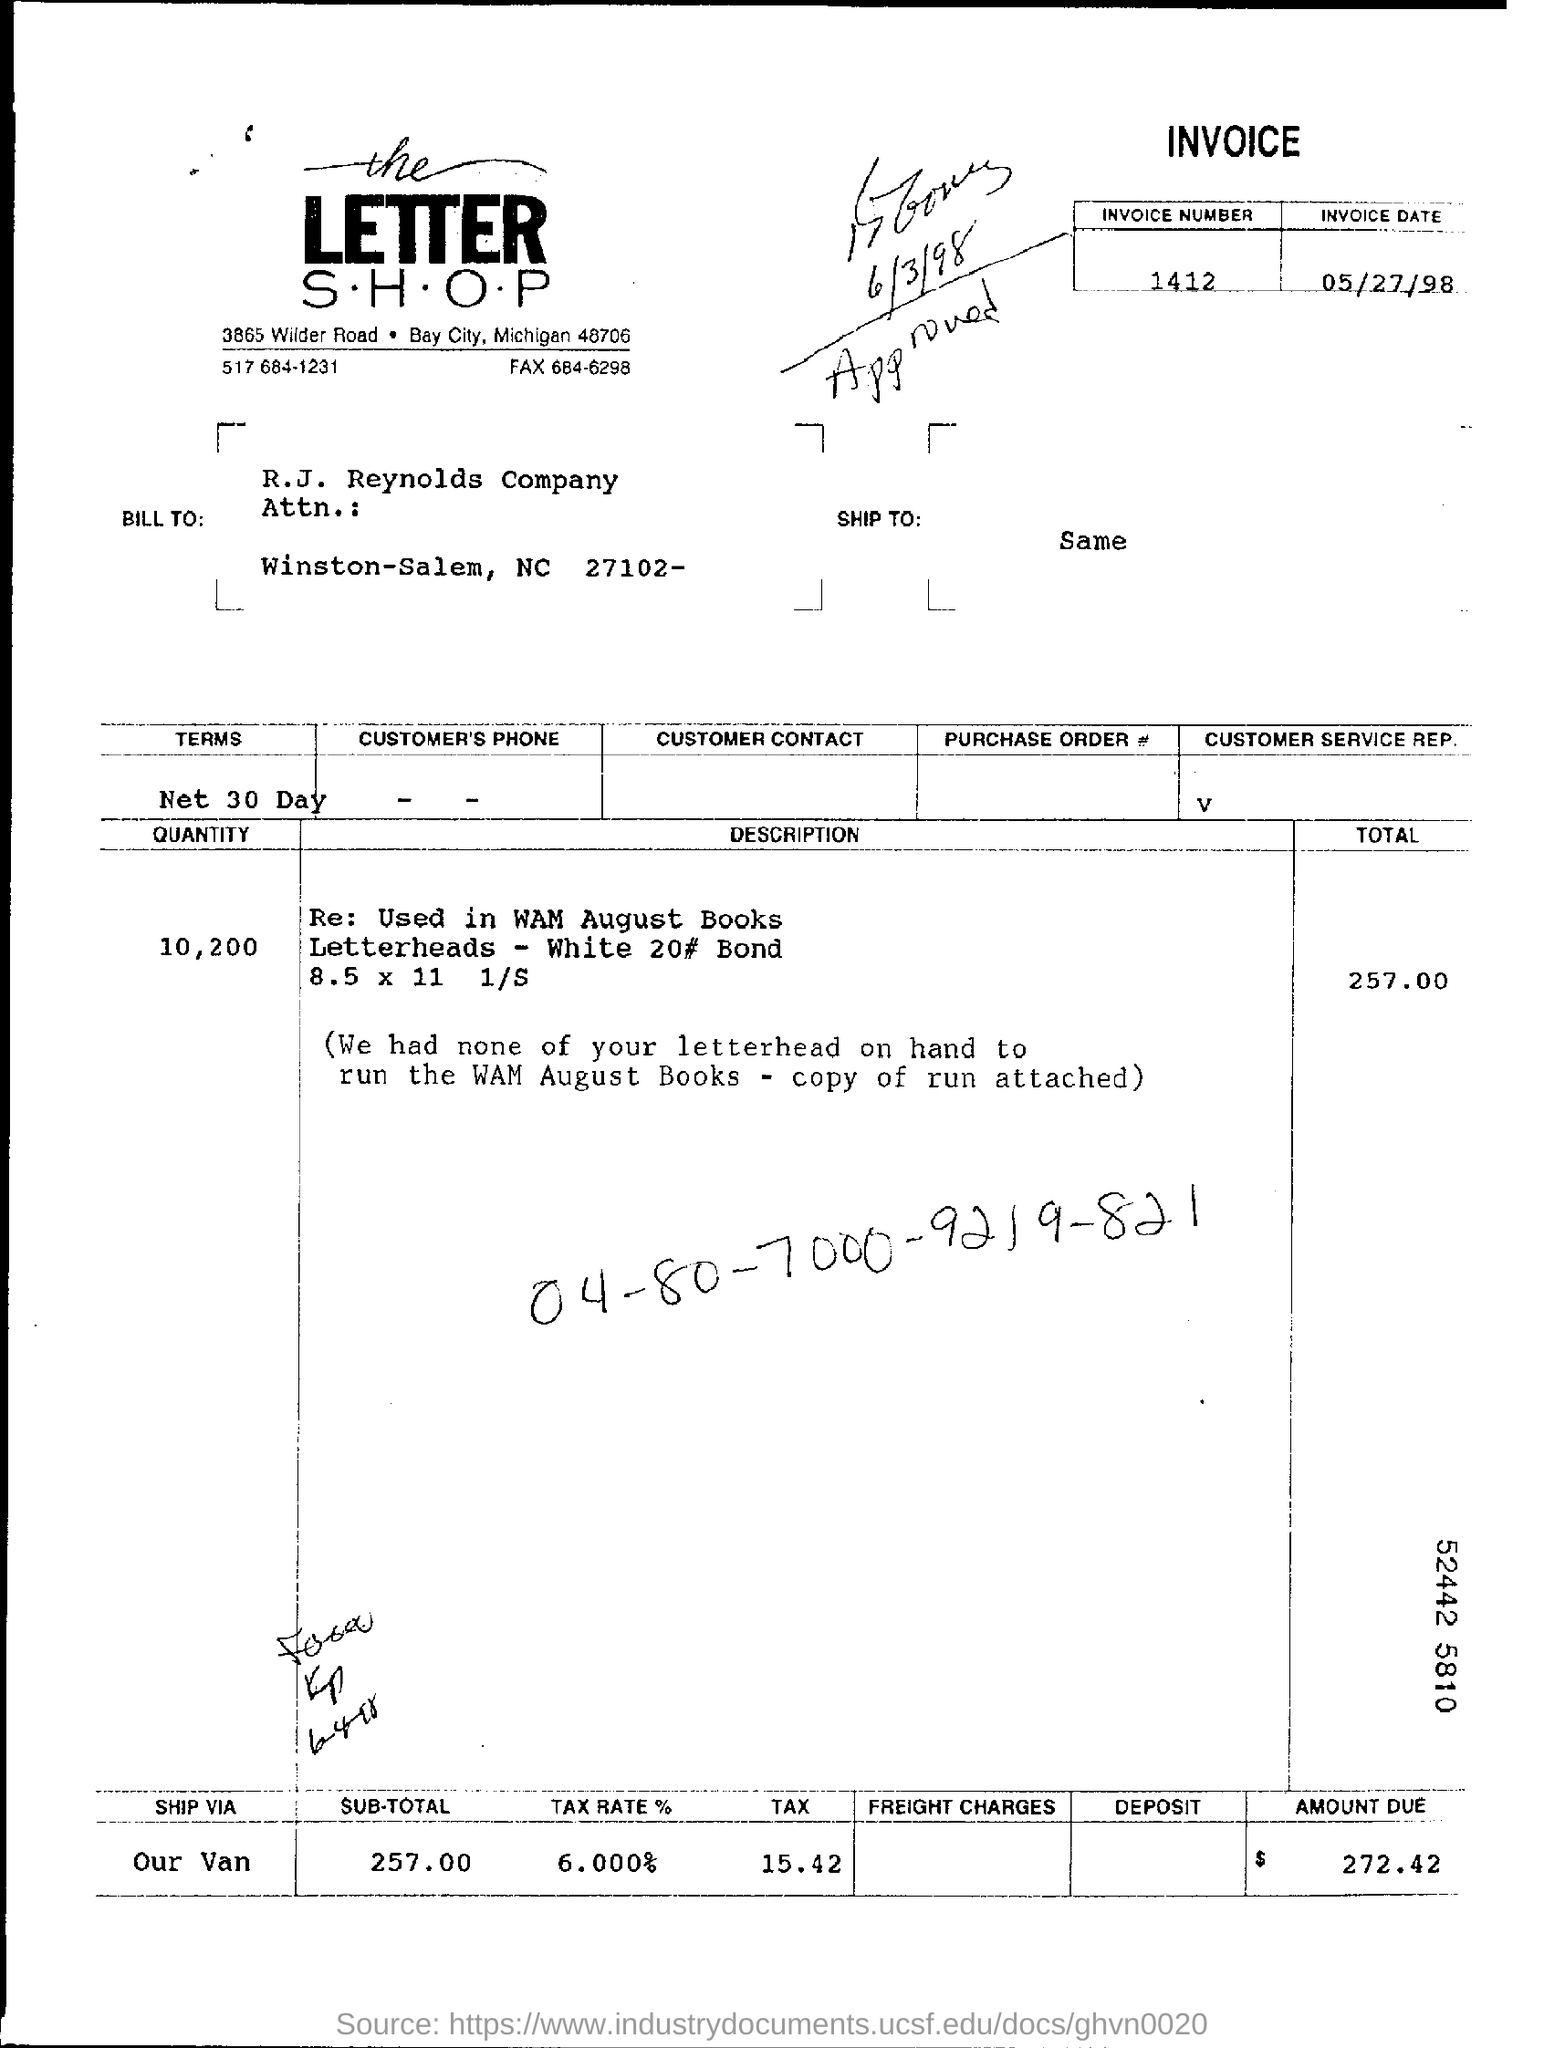Identify some key points in this picture. The invoice date is May 27, 1998. The total is 257.00. Please provide the invoice number, which is 1412... The quantity is 10,200. 